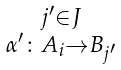Convert formula to latex. <formula><loc_0><loc_0><loc_500><loc_500>\begin{smallmatrix} j ^ { \prime } \in J \\ \alpha ^ { \prime } \colon A _ { i } \to B _ { j ^ { \prime } } \end{smallmatrix}</formula> 